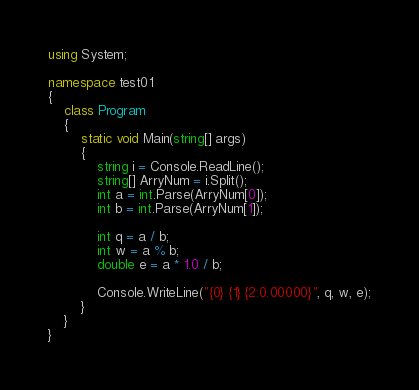<code> <loc_0><loc_0><loc_500><loc_500><_C#_>using System;

namespace test01
{
    class Program
    {
        static void Main(string[] args)
        {
            string i = Console.ReadLine();
            string[] ArryNum = i.Split();
            int a = int.Parse(ArryNum[0]);
            int b = int.Parse(ArryNum[1]);

            int q = a / b;
            int w = a % b;
            double e = a * 1.0 / b;

            Console.WriteLine("{0} {1} {2:0.00000}", q, w, e);
        }
    }
}</code> 